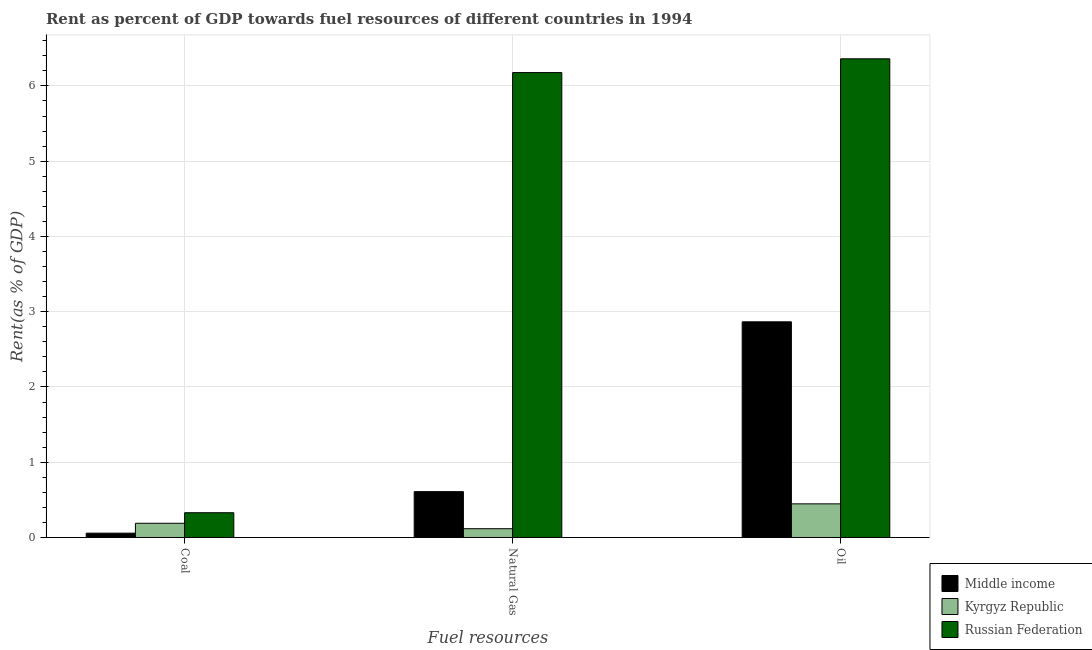How many groups of bars are there?
Make the answer very short. 3. Are the number of bars per tick equal to the number of legend labels?
Keep it short and to the point. Yes. How many bars are there on the 3rd tick from the left?
Give a very brief answer. 3. What is the label of the 2nd group of bars from the left?
Offer a terse response. Natural Gas. What is the rent towards oil in Russian Federation?
Ensure brevity in your answer.  6.36. Across all countries, what is the maximum rent towards natural gas?
Your response must be concise. 6.18. Across all countries, what is the minimum rent towards natural gas?
Make the answer very short. 0.12. In which country was the rent towards oil maximum?
Give a very brief answer. Russian Federation. In which country was the rent towards natural gas minimum?
Keep it short and to the point. Kyrgyz Republic. What is the total rent towards coal in the graph?
Your response must be concise. 0.58. What is the difference between the rent towards natural gas in Kyrgyz Republic and that in Middle income?
Give a very brief answer. -0.49. What is the difference between the rent towards oil in Kyrgyz Republic and the rent towards coal in Middle income?
Provide a succinct answer. 0.39. What is the average rent towards oil per country?
Your response must be concise. 3.22. What is the difference between the rent towards oil and rent towards natural gas in Kyrgyz Republic?
Make the answer very short. 0.33. In how many countries, is the rent towards natural gas greater than 5.8 %?
Offer a terse response. 1. What is the ratio of the rent towards natural gas in Russian Federation to that in Kyrgyz Republic?
Your answer should be compact. 52.97. Is the rent towards oil in Russian Federation less than that in Middle income?
Your answer should be very brief. No. What is the difference between the highest and the second highest rent towards oil?
Your answer should be compact. 3.49. What is the difference between the highest and the lowest rent towards natural gas?
Offer a terse response. 6.06. In how many countries, is the rent towards natural gas greater than the average rent towards natural gas taken over all countries?
Make the answer very short. 1. What does the 1st bar from the left in Coal represents?
Your answer should be very brief. Middle income. What does the 3rd bar from the right in Coal represents?
Provide a succinct answer. Middle income. How many countries are there in the graph?
Your answer should be compact. 3. Are the values on the major ticks of Y-axis written in scientific E-notation?
Offer a very short reply. No. Does the graph contain any zero values?
Your answer should be compact. No. Does the graph contain grids?
Provide a short and direct response. Yes. How are the legend labels stacked?
Provide a short and direct response. Vertical. What is the title of the graph?
Provide a short and direct response. Rent as percent of GDP towards fuel resources of different countries in 1994. Does "Puerto Rico" appear as one of the legend labels in the graph?
Provide a succinct answer. No. What is the label or title of the X-axis?
Make the answer very short. Fuel resources. What is the label or title of the Y-axis?
Make the answer very short. Rent(as % of GDP). What is the Rent(as % of GDP) in Middle income in Coal?
Provide a succinct answer. 0.06. What is the Rent(as % of GDP) in Kyrgyz Republic in Coal?
Your answer should be compact. 0.19. What is the Rent(as % of GDP) of Russian Federation in Coal?
Ensure brevity in your answer.  0.33. What is the Rent(as % of GDP) of Middle income in Natural Gas?
Provide a succinct answer. 0.61. What is the Rent(as % of GDP) of Kyrgyz Republic in Natural Gas?
Provide a short and direct response. 0.12. What is the Rent(as % of GDP) in Russian Federation in Natural Gas?
Provide a succinct answer. 6.18. What is the Rent(as % of GDP) in Middle income in Oil?
Give a very brief answer. 2.87. What is the Rent(as % of GDP) in Kyrgyz Republic in Oil?
Provide a succinct answer. 0.45. What is the Rent(as % of GDP) in Russian Federation in Oil?
Keep it short and to the point. 6.36. Across all Fuel resources, what is the maximum Rent(as % of GDP) of Middle income?
Your answer should be compact. 2.87. Across all Fuel resources, what is the maximum Rent(as % of GDP) in Kyrgyz Republic?
Offer a terse response. 0.45. Across all Fuel resources, what is the maximum Rent(as % of GDP) of Russian Federation?
Offer a terse response. 6.36. Across all Fuel resources, what is the minimum Rent(as % of GDP) of Middle income?
Ensure brevity in your answer.  0.06. Across all Fuel resources, what is the minimum Rent(as % of GDP) in Kyrgyz Republic?
Offer a terse response. 0.12. Across all Fuel resources, what is the minimum Rent(as % of GDP) of Russian Federation?
Your answer should be compact. 0.33. What is the total Rent(as % of GDP) of Middle income in the graph?
Give a very brief answer. 3.53. What is the total Rent(as % of GDP) of Kyrgyz Republic in the graph?
Your answer should be very brief. 0.75. What is the total Rent(as % of GDP) in Russian Federation in the graph?
Offer a terse response. 12.87. What is the difference between the Rent(as % of GDP) of Middle income in Coal and that in Natural Gas?
Make the answer very short. -0.55. What is the difference between the Rent(as % of GDP) of Kyrgyz Republic in Coal and that in Natural Gas?
Offer a terse response. 0.07. What is the difference between the Rent(as % of GDP) in Russian Federation in Coal and that in Natural Gas?
Your response must be concise. -5.85. What is the difference between the Rent(as % of GDP) in Middle income in Coal and that in Oil?
Ensure brevity in your answer.  -2.81. What is the difference between the Rent(as % of GDP) of Kyrgyz Republic in Coal and that in Oil?
Provide a short and direct response. -0.26. What is the difference between the Rent(as % of GDP) of Russian Federation in Coal and that in Oil?
Offer a very short reply. -6.03. What is the difference between the Rent(as % of GDP) in Middle income in Natural Gas and that in Oil?
Provide a succinct answer. -2.26. What is the difference between the Rent(as % of GDP) in Kyrgyz Republic in Natural Gas and that in Oil?
Provide a short and direct response. -0.33. What is the difference between the Rent(as % of GDP) of Russian Federation in Natural Gas and that in Oil?
Your answer should be very brief. -0.18. What is the difference between the Rent(as % of GDP) of Middle income in Coal and the Rent(as % of GDP) of Kyrgyz Republic in Natural Gas?
Make the answer very short. -0.06. What is the difference between the Rent(as % of GDP) in Middle income in Coal and the Rent(as % of GDP) in Russian Federation in Natural Gas?
Your answer should be very brief. -6.12. What is the difference between the Rent(as % of GDP) in Kyrgyz Republic in Coal and the Rent(as % of GDP) in Russian Federation in Natural Gas?
Provide a succinct answer. -5.99. What is the difference between the Rent(as % of GDP) in Middle income in Coal and the Rent(as % of GDP) in Kyrgyz Republic in Oil?
Ensure brevity in your answer.  -0.39. What is the difference between the Rent(as % of GDP) of Middle income in Coal and the Rent(as % of GDP) of Russian Federation in Oil?
Keep it short and to the point. -6.3. What is the difference between the Rent(as % of GDP) in Kyrgyz Republic in Coal and the Rent(as % of GDP) in Russian Federation in Oil?
Provide a short and direct response. -6.17. What is the difference between the Rent(as % of GDP) of Middle income in Natural Gas and the Rent(as % of GDP) of Kyrgyz Republic in Oil?
Offer a terse response. 0.16. What is the difference between the Rent(as % of GDP) of Middle income in Natural Gas and the Rent(as % of GDP) of Russian Federation in Oil?
Your answer should be compact. -5.75. What is the difference between the Rent(as % of GDP) in Kyrgyz Republic in Natural Gas and the Rent(as % of GDP) in Russian Federation in Oil?
Provide a succinct answer. -6.24. What is the average Rent(as % of GDP) of Middle income per Fuel resources?
Your answer should be very brief. 1.18. What is the average Rent(as % of GDP) in Kyrgyz Republic per Fuel resources?
Make the answer very short. 0.25. What is the average Rent(as % of GDP) of Russian Federation per Fuel resources?
Offer a terse response. 4.29. What is the difference between the Rent(as % of GDP) in Middle income and Rent(as % of GDP) in Kyrgyz Republic in Coal?
Give a very brief answer. -0.13. What is the difference between the Rent(as % of GDP) of Middle income and Rent(as % of GDP) of Russian Federation in Coal?
Your answer should be very brief. -0.27. What is the difference between the Rent(as % of GDP) in Kyrgyz Republic and Rent(as % of GDP) in Russian Federation in Coal?
Keep it short and to the point. -0.14. What is the difference between the Rent(as % of GDP) in Middle income and Rent(as % of GDP) in Kyrgyz Republic in Natural Gas?
Give a very brief answer. 0.49. What is the difference between the Rent(as % of GDP) in Middle income and Rent(as % of GDP) in Russian Federation in Natural Gas?
Provide a succinct answer. -5.57. What is the difference between the Rent(as % of GDP) of Kyrgyz Republic and Rent(as % of GDP) of Russian Federation in Natural Gas?
Give a very brief answer. -6.06. What is the difference between the Rent(as % of GDP) in Middle income and Rent(as % of GDP) in Kyrgyz Republic in Oil?
Offer a very short reply. 2.42. What is the difference between the Rent(as % of GDP) in Middle income and Rent(as % of GDP) in Russian Federation in Oil?
Offer a terse response. -3.49. What is the difference between the Rent(as % of GDP) of Kyrgyz Republic and Rent(as % of GDP) of Russian Federation in Oil?
Your answer should be compact. -5.91. What is the ratio of the Rent(as % of GDP) of Middle income in Coal to that in Natural Gas?
Make the answer very short. 0.09. What is the ratio of the Rent(as % of GDP) of Kyrgyz Republic in Coal to that in Natural Gas?
Your response must be concise. 1.62. What is the ratio of the Rent(as % of GDP) in Russian Federation in Coal to that in Natural Gas?
Provide a short and direct response. 0.05. What is the ratio of the Rent(as % of GDP) of Middle income in Coal to that in Oil?
Offer a terse response. 0.02. What is the ratio of the Rent(as % of GDP) in Kyrgyz Republic in Coal to that in Oil?
Your response must be concise. 0.42. What is the ratio of the Rent(as % of GDP) of Russian Federation in Coal to that in Oil?
Make the answer very short. 0.05. What is the ratio of the Rent(as % of GDP) of Middle income in Natural Gas to that in Oil?
Offer a terse response. 0.21. What is the ratio of the Rent(as % of GDP) of Kyrgyz Republic in Natural Gas to that in Oil?
Your response must be concise. 0.26. What is the ratio of the Rent(as % of GDP) in Russian Federation in Natural Gas to that in Oil?
Your answer should be very brief. 0.97. What is the difference between the highest and the second highest Rent(as % of GDP) in Middle income?
Offer a very short reply. 2.26. What is the difference between the highest and the second highest Rent(as % of GDP) of Kyrgyz Republic?
Provide a short and direct response. 0.26. What is the difference between the highest and the second highest Rent(as % of GDP) of Russian Federation?
Your answer should be compact. 0.18. What is the difference between the highest and the lowest Rent(as % of GDP) in Middle income?
Give a very brief answer. 2.81. What is the difference between the highest and the lowest Rent(as % of GDP) of Kyrgyz Republic?
Ensure brevity in your answer.  0.33. What is the difference between the highest and the lowest Rent(as % of GDP) of Russian Federation?
Ensure brevity in your answer.  6.03. 